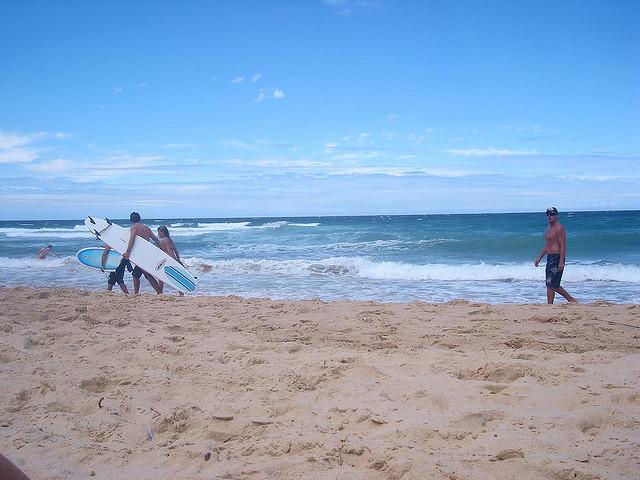Is the person on the right looking at the camera?
Quick response, please. Yes. Are the waves very high?
Short answer required. No. Is the sky clear?
Keep it brief. Yes. Is it cold?
Answer briefly. No. How many people are on the beach?
Write a very short answer. 4. What are the people on the left about to do?
Write a very short answer. Surf. 